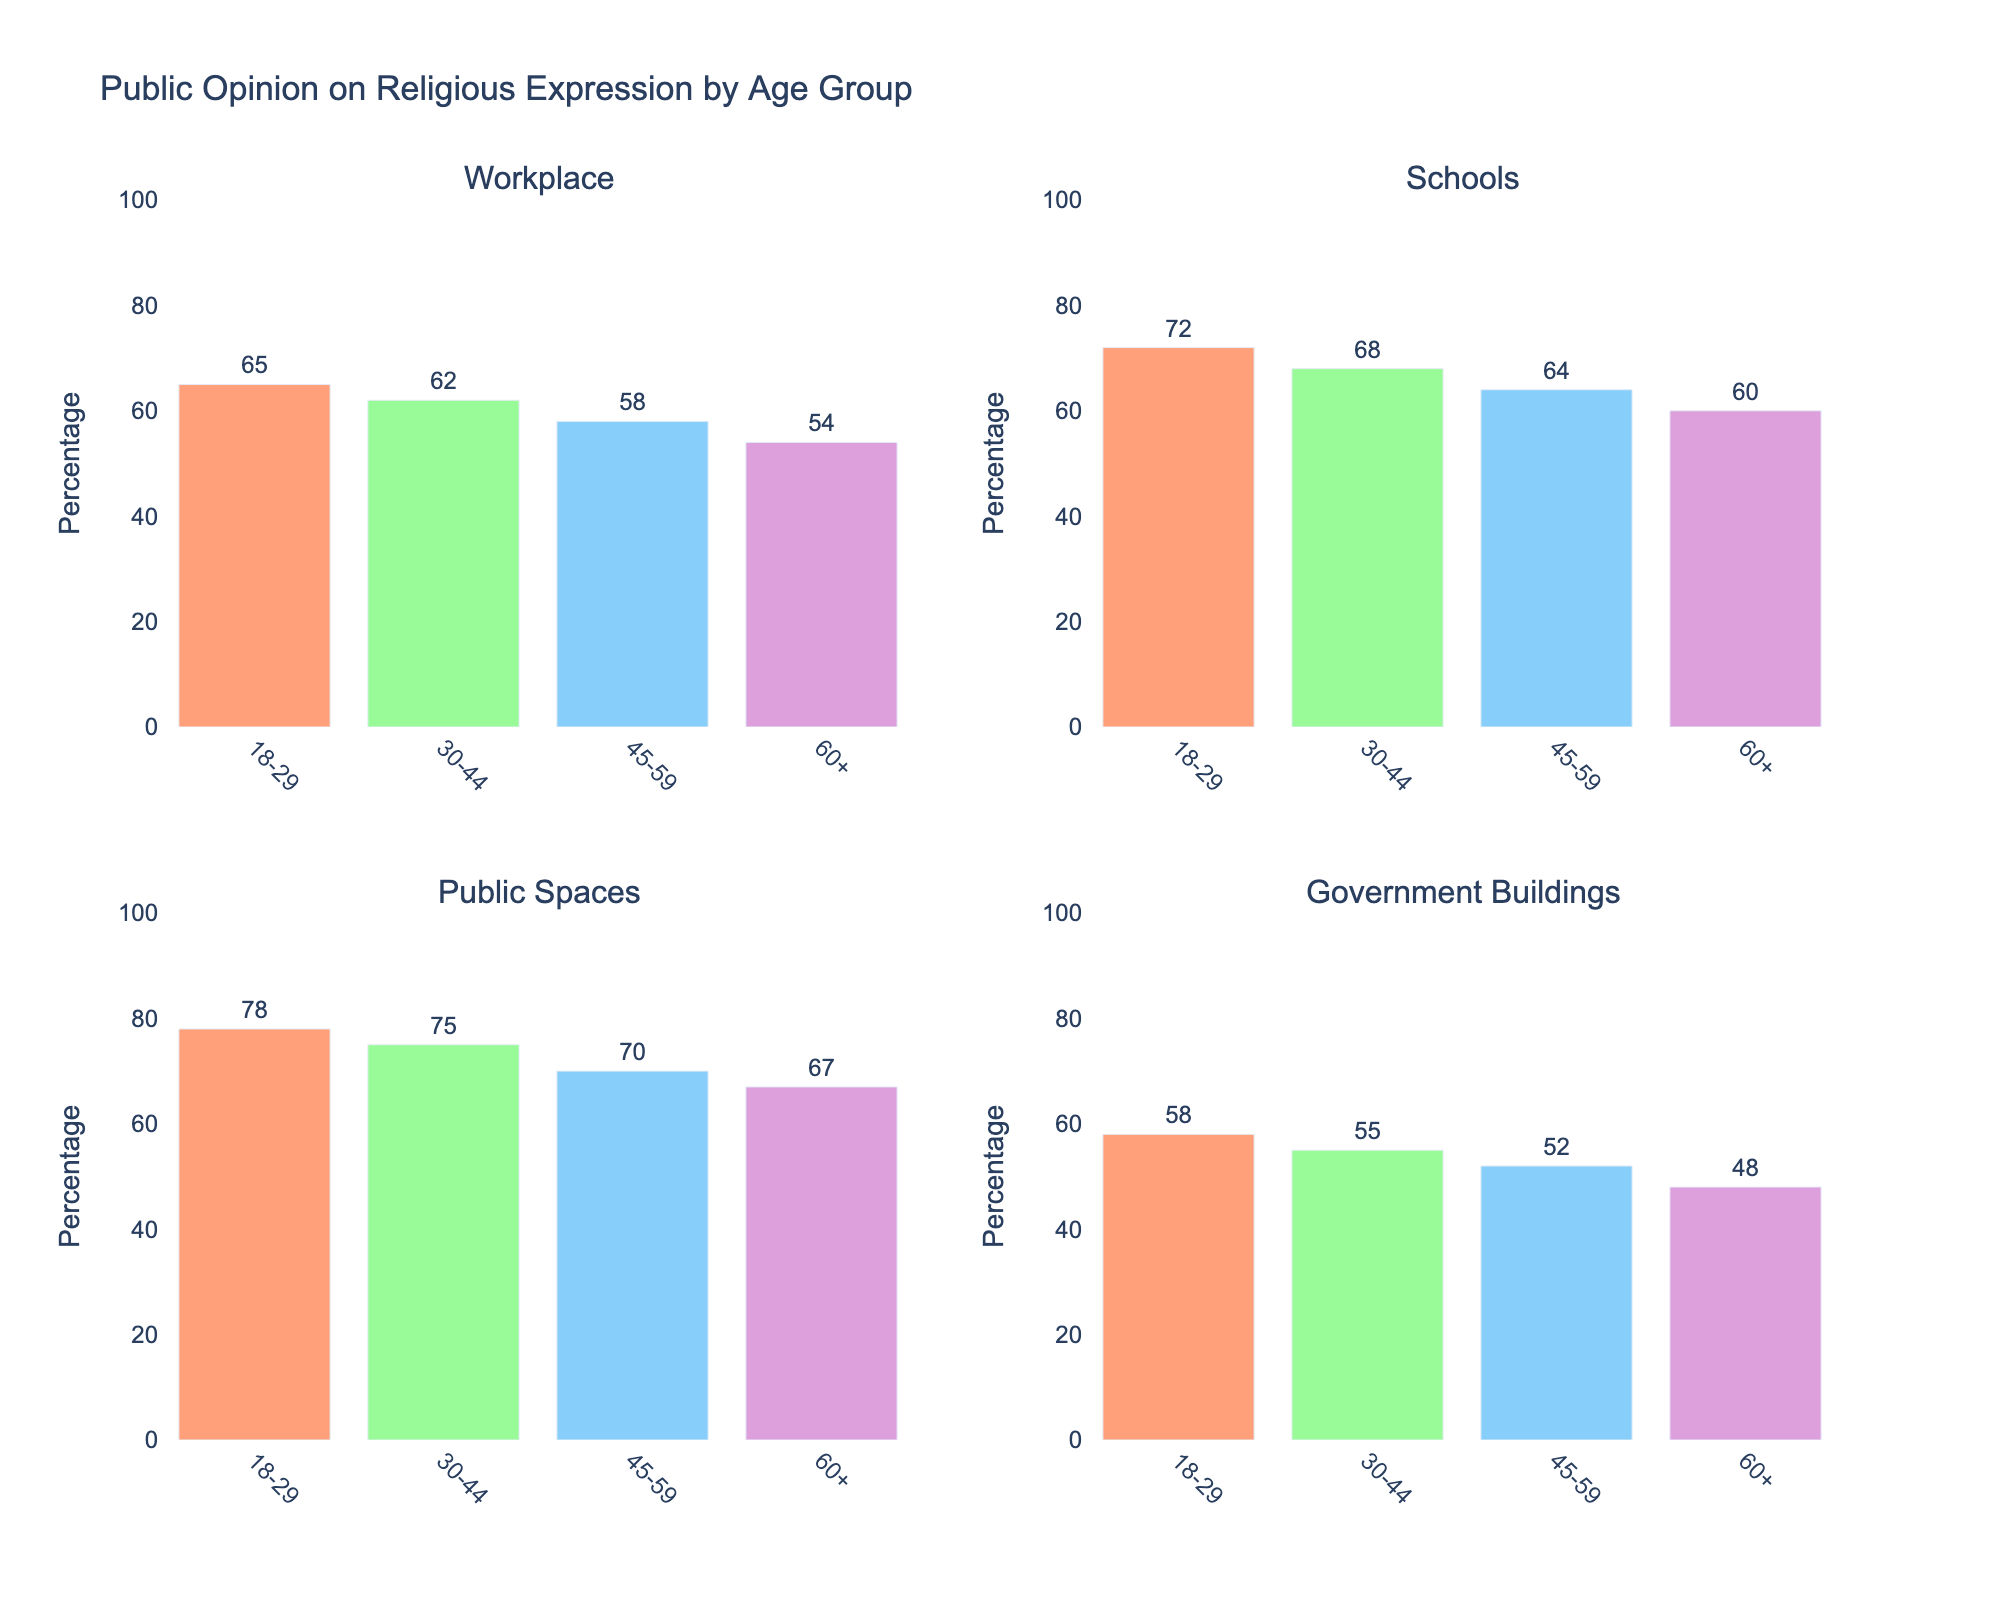What's the title of the figure? The title of the figure is prominently displayed above all the subplots. By observing the top of the image, we can see the title text.
Answer: Document Acquisition Rates from Various Sources (1920-2020) What time period does the data cover? By looking at the x-axis at the bottom of any of the subplots, it is evident that the time period covered ranges from 1920 to 2020.
Answer: 1920-2020 Which source had the highest acquisition rate in 2020? To find the highest acquisition rate in 2020, compare the y-values for each source in 2020. The government archives had the highest rate.
Answer: Government Archives How many sources are compared in this figure? By counting the number of subplots and noting the labels for each subplot, we see that there are five sources: Government Archives, Private Collections, National Library, University Libraries, and Museums.
Answer: 5 What's the acquisition rate for university libraries in 1960? Look at the subplot for University Libraries and find the data point corresponding to 1960 on the x-axis. The y-value for this point is the acquisition rate.
Answer: 10 Which source shows the greatest overall increase in document acquisition rate from 1920 to 2020? Calculate the difference in acquisition rates for each source between 1920 and 2020 by subtracting the 1920 value from the 2020 value. Government Archives show the largest difference (80-15=65).
Answer: Government Archives Compare the acquisition rates of Private Collections and Museums in 1980. Which one is higher? Look at the subplots for Private Collections and Museums and find the data points for 1980. Compare the y-values for these points. Private Collections had a higher rate.
Answer: Private Collections What is the average acquisition rate of National Library across all the years presented? Add up the acquisition rates of National Library across all the years and divide by the number of years (8+12+18+25+40+60)/6. The average is calculated as (8+12+18+25+40+60)/6 = 27.17 (rounded to 2 decimal places).
Answer: 27.17 Does any source show a consistent rate of increase in acquisitions across the years? By analyzing each subplot, all sources show a consistent increase, but the Government Archives have a particularly steady and linear-looking increase.
Answer: Yes, particularly Government Archives 